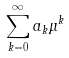Convert formula to latex. <formula><loc_0><loc_0><loc_500><loc_500>\sum _ { k = 0 } ^ { \infty } a _ { k } \mu ^ { k }</formula> 